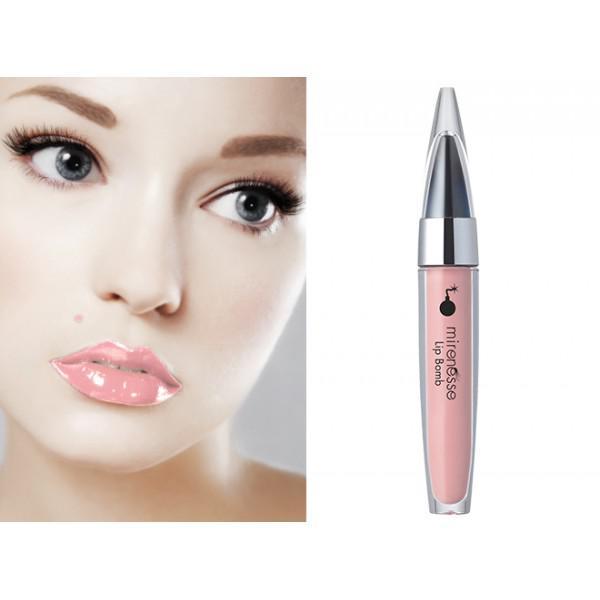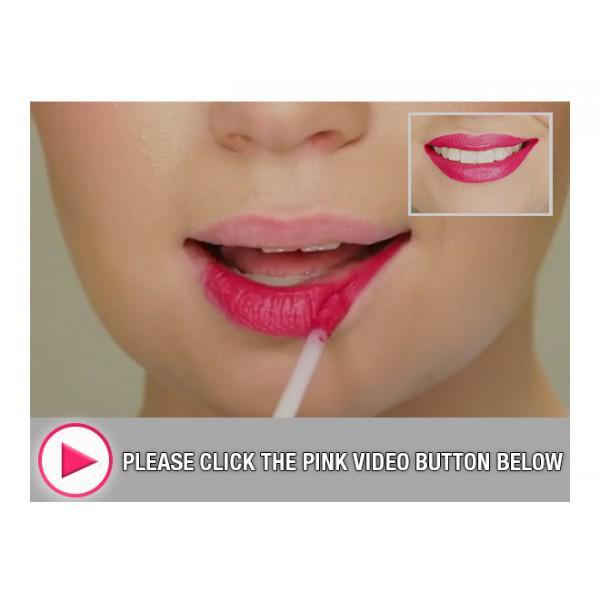The first image is the image on the left, the second image is the image on the right. For the images displayed, is the sentence "Left image shows a pink lipstick with cap on, and image of glossy lips." factually correct? Answer yes or no. Yes. The first image is the image on the left, the second image is the image on the right. For the images shown, is this caption "there is exactly one pair of lips in the image on the left" true? Answer yes or no. Yes. 